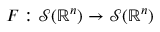Convert formula to latex. <formula><loc_0><loc_0><loc_500><loc_500>F \colon { \mathcal { S } } ( \mathbb { R } ^ { n } ) \to { \mathcal { S } } ( \mathbb { R } ^ { n } )</formula> 